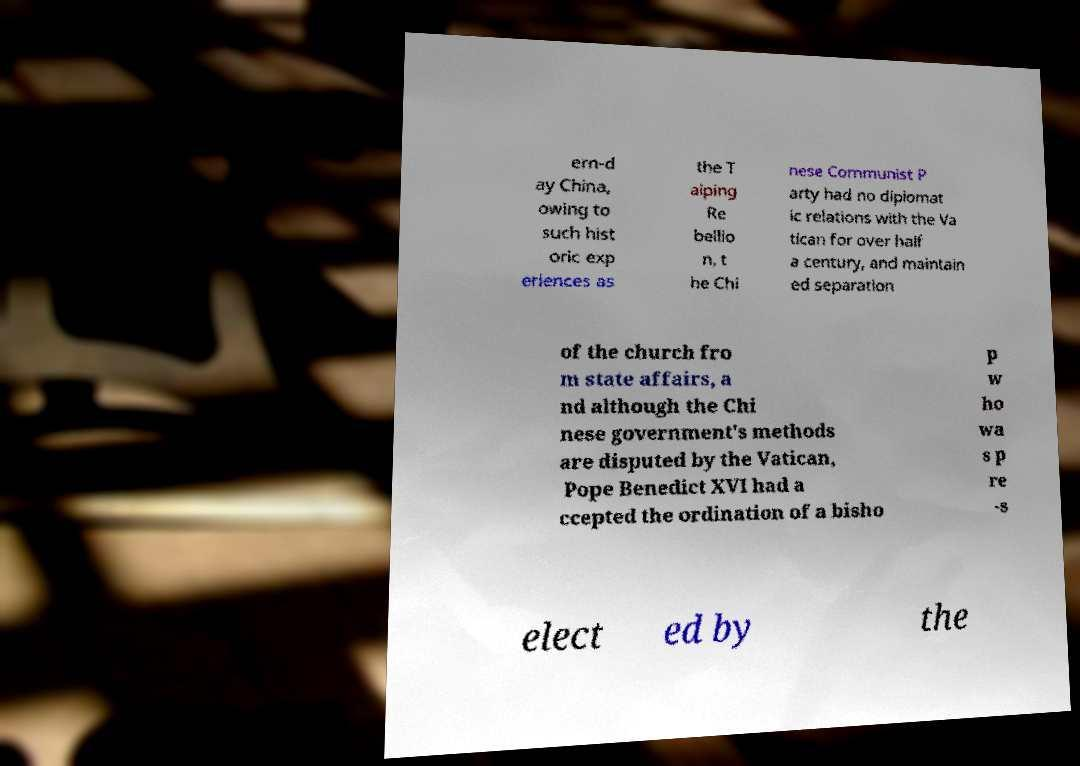For documentation purposes, I need the text within this image transcribed. Could you provide that? ern-d ay China, owing to such hist oric exp eriences as the T aiping Re bellio n, t he Chi nese Communist P arty had no diplomat ic relations with the Va tican for over half a century, and maintain ed separation of the church fro m state affairs, a nd although the Chi nese government's methods are disputed by the Vatican, Pope Benedict XVI had a ccepted the ordination of a bisho p w ho wa s p re -s elect ed by the 